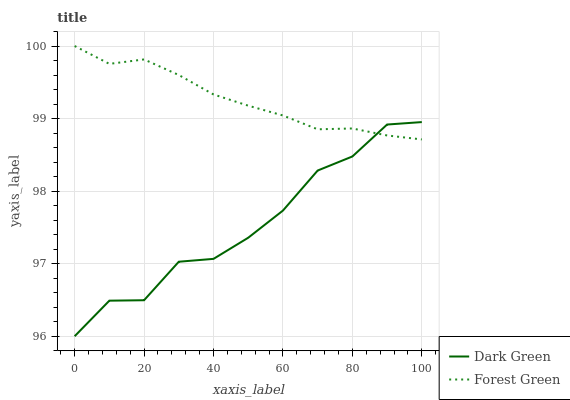Does Dark Green have the minimum area under the curve?
Answer yes or no. Yes. Does Forest Green have the maximum area under the curve?
Answer yes or no. Yes. Does Dark Green have the maximum area under the curve?
Answer yes or no. No. Is Forest Green the smoothest?
Answer yes or no. Yes. Is Dark Green the roughest?
Answer yes or no. Yes. Is Dark Green the smoothest?
Answer yes or no. No. Does Dark Green have the lowest value?
Answer yes or no. Yes. Does Forest Green have the highest value?
Answer yes or no. Yes. Does Dark Green have the highest value?
Answer yes or no. No. Does Forest Green intersect Dark Green?
Answer yes or no. Yes. Is Forest Green less than Dark Green?
Answer yes or no. No. Is Forest Green greater than Dark Green?
Answer yes or no. No. 